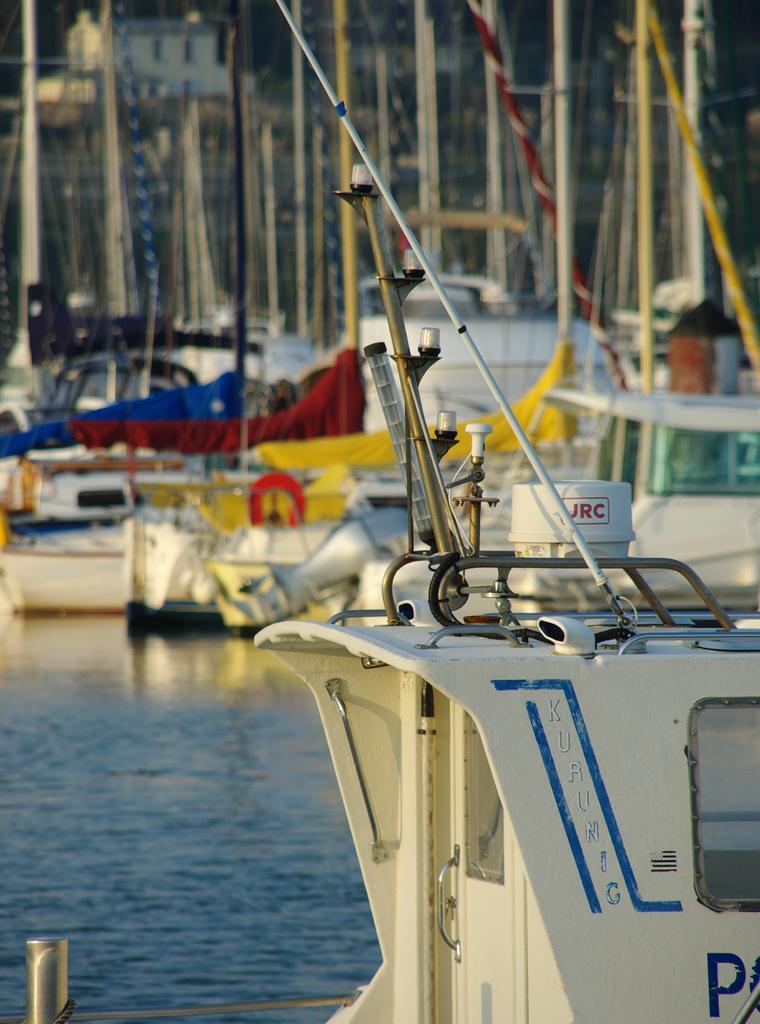In one or two sentences, can you explain what this image depicts? This image is taken outdoors. On the left side of the image there is a river with water. On the right side of the image there are many boats on the river and there are many poles and iron bars. 